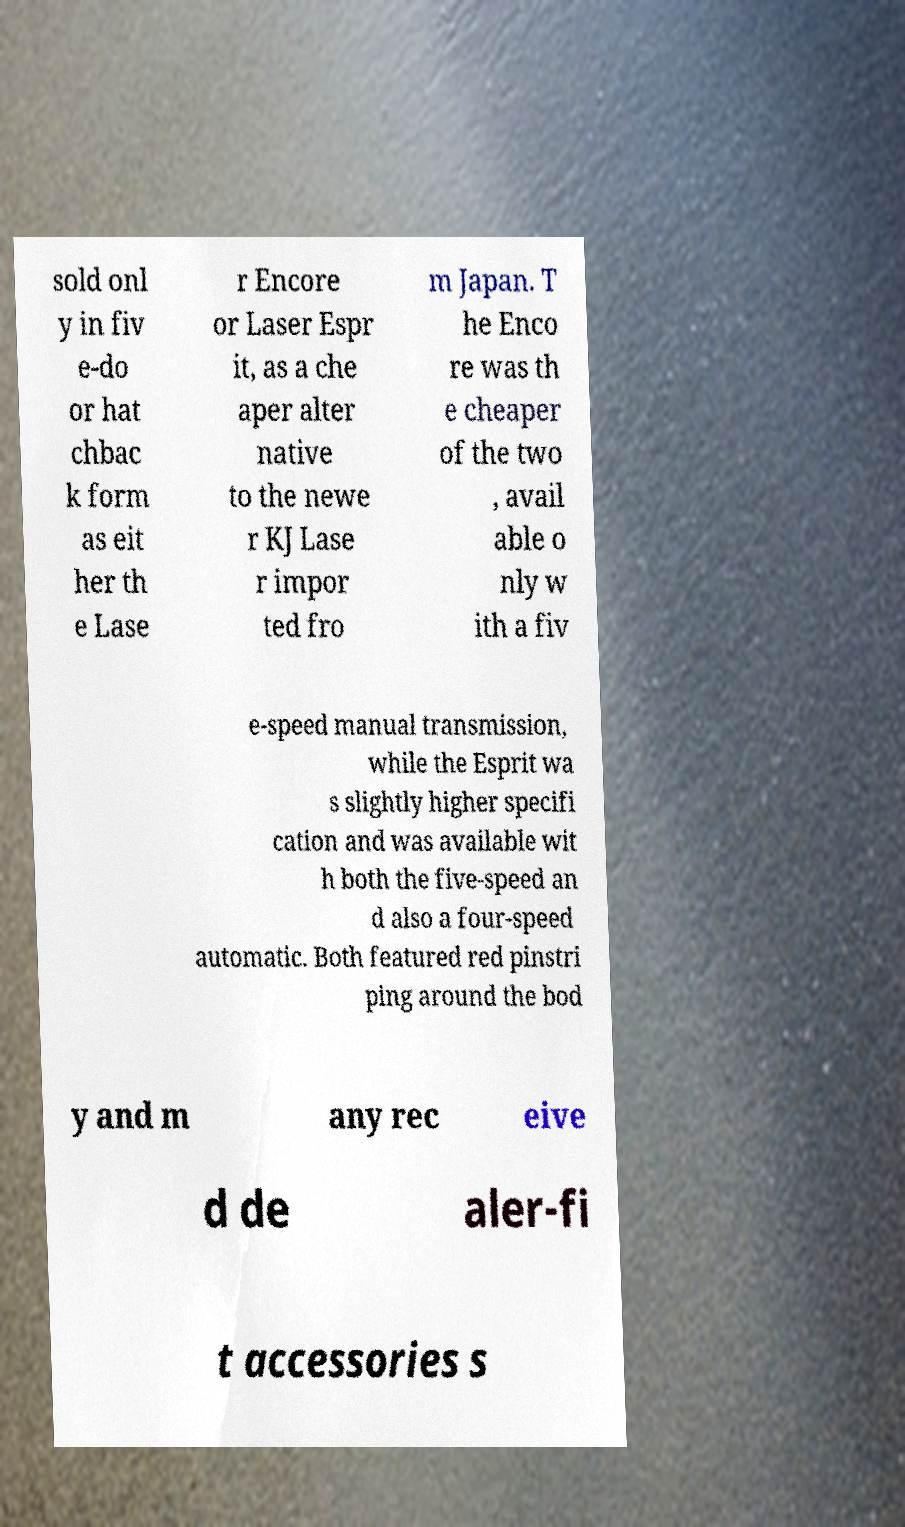There's text embedded in this image that I need extracted. Can you transcribe it verbatim? sold onl y in fiv e-do or hat chbac k form as eit her th e Lase r Encore or Laser Espr it, as a che aper alter native to the newe r KJ Lase r impor ted fro m Japan. T he Enco re was th e cheaper of the two , avail able o nly w ith a fiv e-speed manual transmission, while the Esprit wa s slightly higher specifi cation and was available wit h both the five-speed an d also a four-speed automatic. Both featured red pinstri ping around the bod y and m any rec eive d de aler-fi t accessories s 